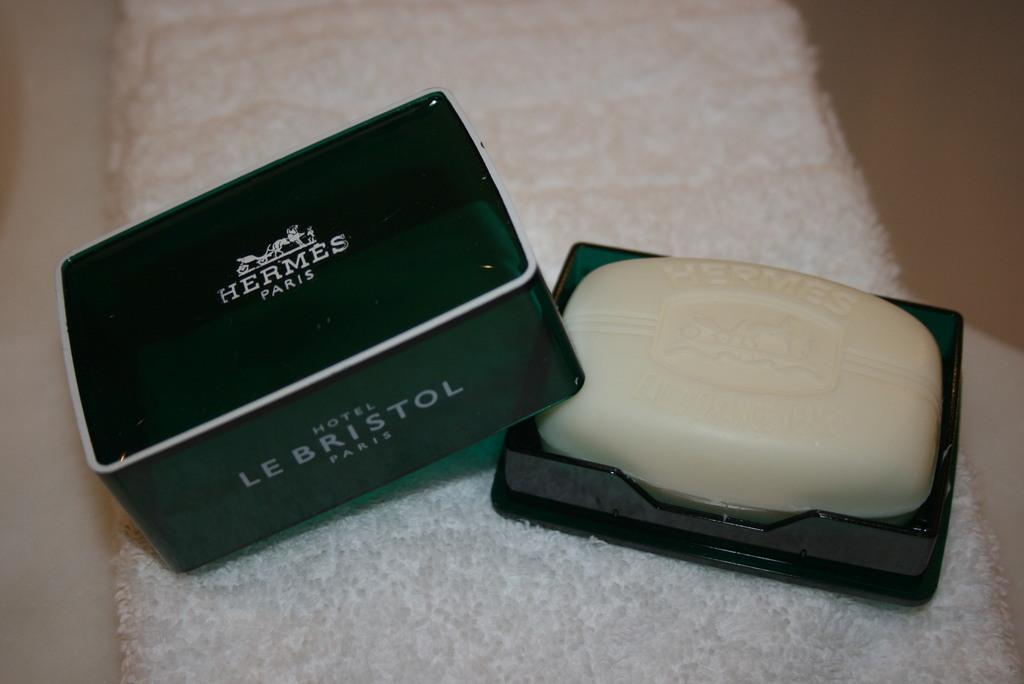What is the main object in the image? There is a cloth in the image. What is placed on the cloth? There is a box with soap on the cloth. What can be seen on the box lid? There is a box lid with writing on it. How does the kite fly in the image? There is no kite present in the image. What type of love is expressed through the writing on the box lid? There is no indication of love or any emotional expression in the image; the writing on the box lid is likely related to the soap or the box itself. 